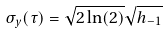Convert formula to latex. <formula><loc_0><loc_0><loc_500><loc_500>\sigma _ { y } ( \tau ) = \sqrt { 2 \ln ( 2 ) } \sqrt { h _ { - 1 } }</formula> 